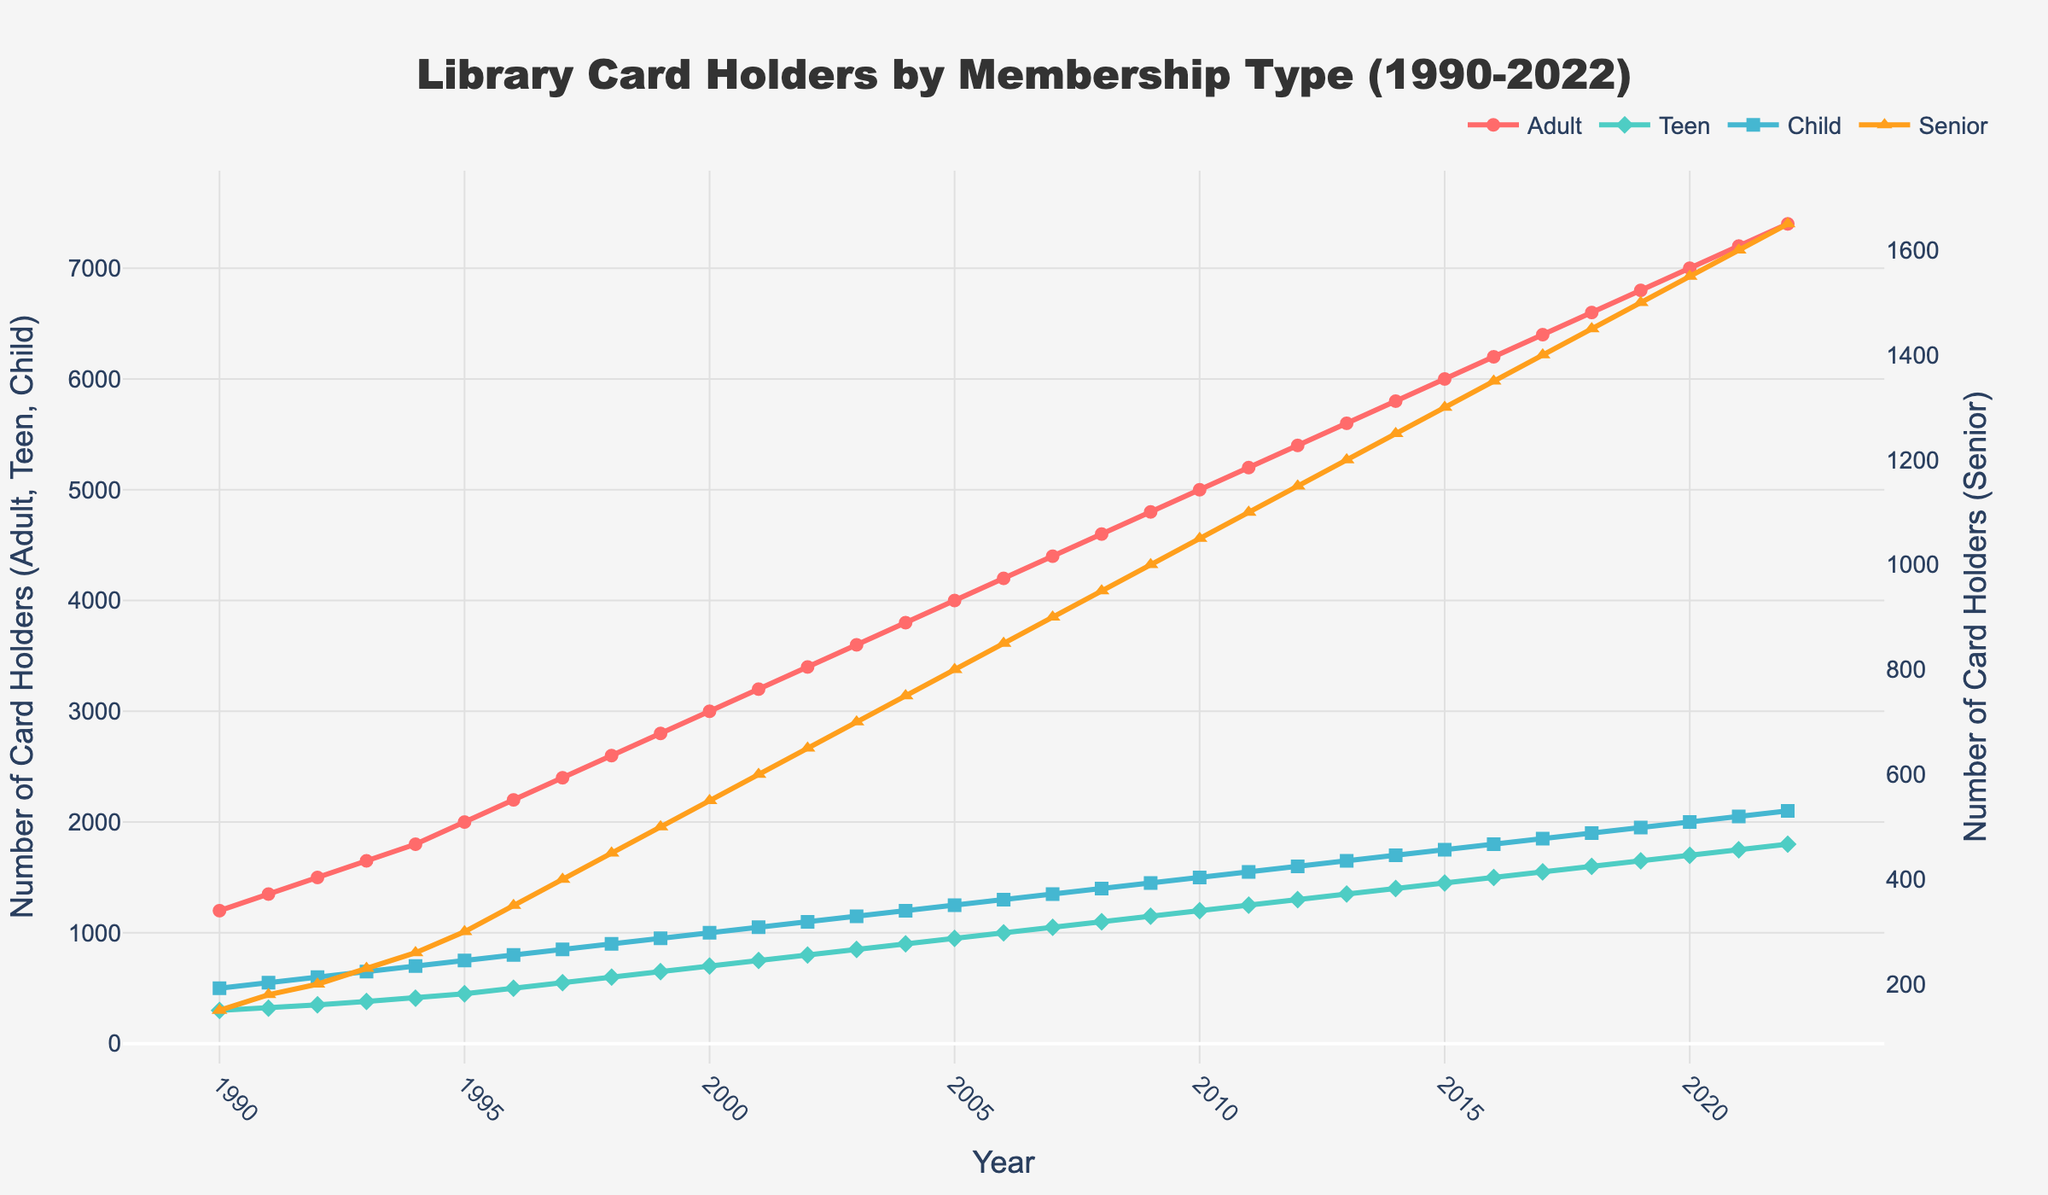What was the number of adult library card holders in 1995? Look for the data point labeled "Adult" in the year 1995. The value is 2000.
Answer: 2000 How much did the number of teen card holders increase from 1991 to 2000? Subtract the number of teen card holders in 1991 from the number in 2000. The values are 700 in 2000 and 320 in 1991. So, 700 - 320 = 380.
Answer: 380 What is the total number of library card holders across all categories in 2010? Sum the number of card holders for Adult, Teen, Child, and Senior in the year 2010. The values are 5000, 1200, 1500, and 1050 respectively. So, 5000 + 1200 + 1500 + 1050 = 8750.
Answer: 8750 Which year had the highest number of child card holders, and what was the number? Identify the highest point in the "Child" series. The highest number is in 2022 with 2100 child card holders.
Answer: 2022, 2100 From the inception up to 2022, which membership type has shown the most significant relative growth, and why? Compare the initial and final values of card holders for each type from 1990 to 2022. Adult grew from 1200 to 7400 (an increase of 6200), Teen from 300 to 1800 (an increase of 1500), Child from 500 to 2100 (an increase of 1600), and Senior from 150 to 1650 (an increase of 1500). The relative growth (final/initial) is most significant for Adults (6200/1200 = ~5.17).
Answer: Adult In which year did the number of senior card holders surpass 800 for the first time? Look for the year in which the "Senior" series first exceeds 800. It first surpasses 800 in the year 2005.
Answer: 2005 What was the difference in the number of total library card holders between 2000 and 2022? Calculate the total card holders for both years and find the difference. In 2000: 3000 + 700 + 1000 + 550 = 5250. In 2022: 7400 + 1800 + 2100 + 1650 = 12950. So, 12950 - 5250 = 7700.
Answer: 7700 